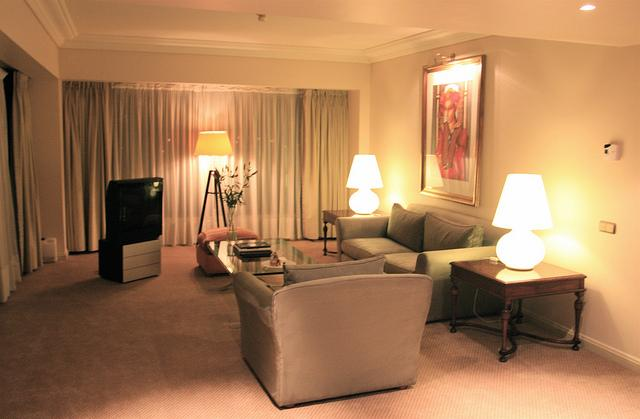What is the large black object used for? Please explain your reasoning. watching television. The large black object is a television set that people can sit around and watch. 